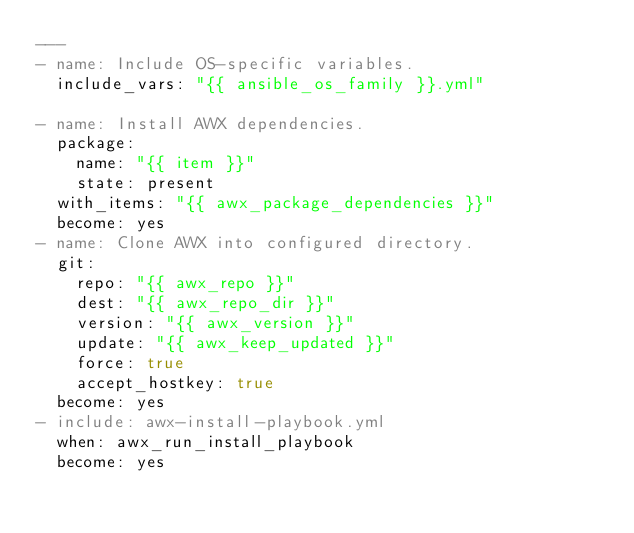Convert code to text. <code><loc_0><loc_0><loc_500><loc_500><_YAML_>---
- name: Include OS-specific variables.
  include_vars: "{{ ansible_os_family }}.yml"

- name: Install AWX dependencies.
  package:
    name: "{{ item }}"
    state: present
  with_items: "{{ awx_package_dependencies }}"
  become: yes
- name: Clone AWX into configured directory.
  git:
    repo: "{{ awx_repo }}"
    dest: "{{ awx_repo_dir }}"
    version: "{{ awx_version }}"
    update: "{{ awx_keep_updated }}"
    force: true
    accept_hostkey: true
  become: yes
- include: awx-install-playbook.yml
  when: awx_run_install_playbook
  become: yes
</code> 